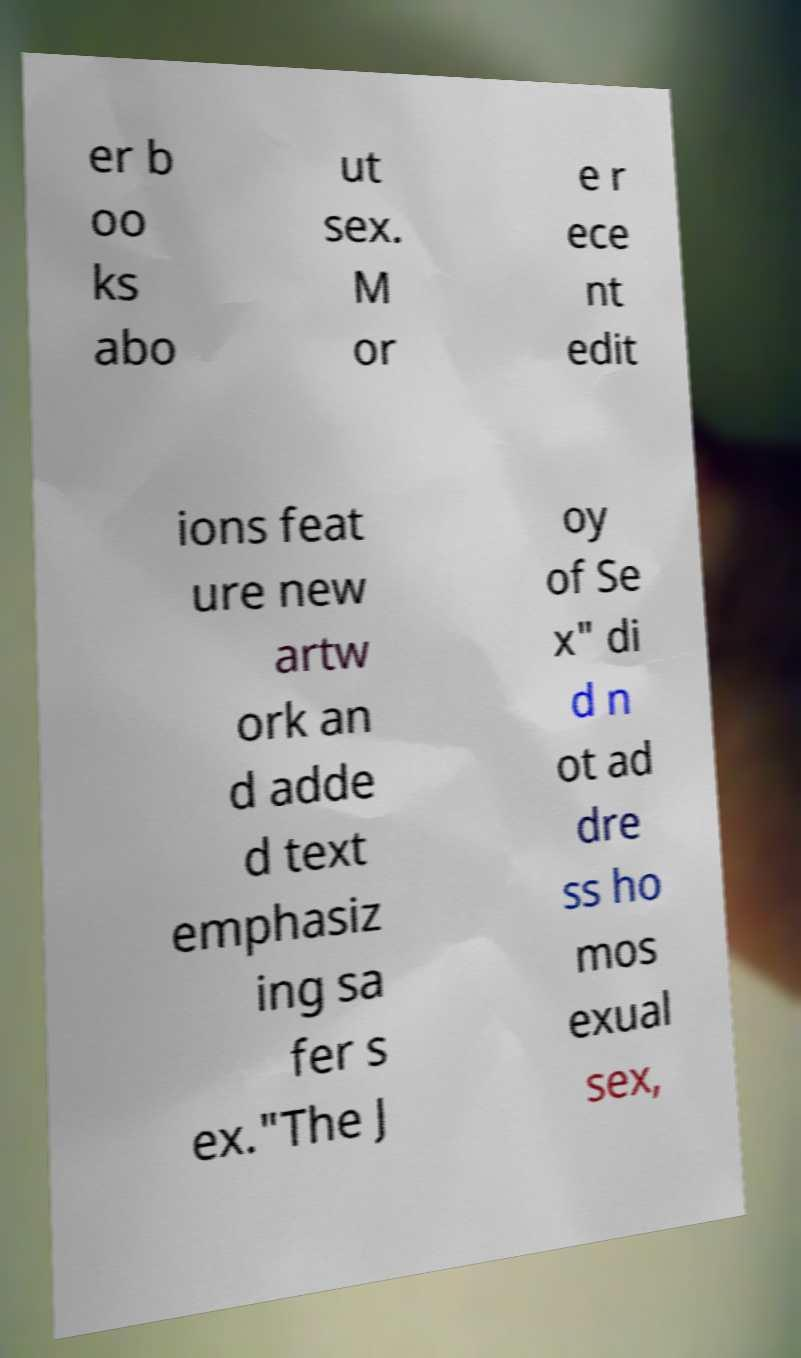What messages or text are displayed in this image? I need them in a readable, typed format. er b oo ks abo ut sex. M or e r ece nt edit ions feat ure new artw ork an d adde d text emphasiz ing sa fer s ex."The J oy of Se x" di d n ot ad dre ss ho mos exual sex, 